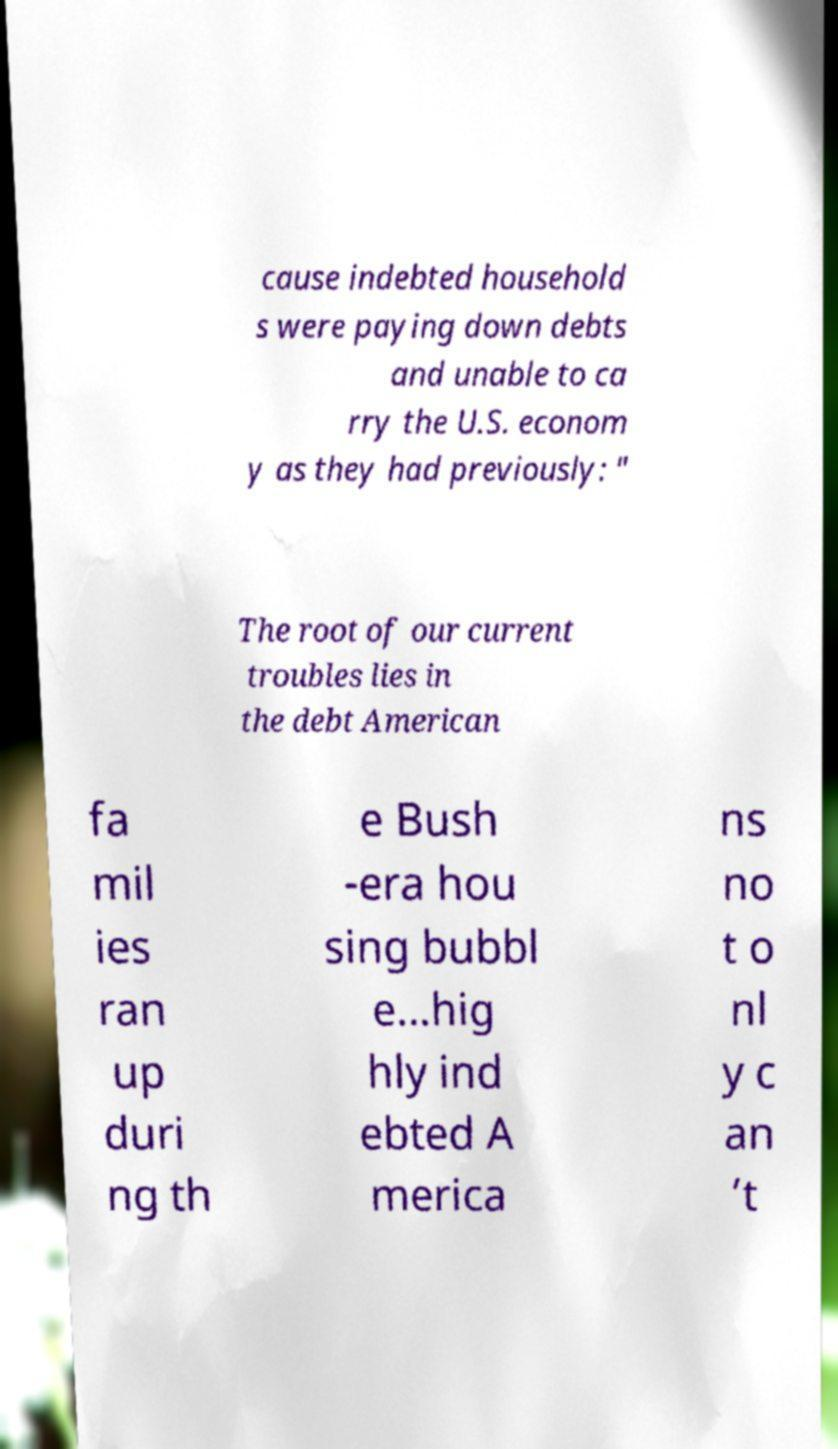For documentation purposes, I need the text within this image transcribed. Could you provide that? cause indebted household s were paying down debts and unable to ca rry the U.S. econom y as they had previously: " The root of our current troubles lies in the debt American fa mil ies ran up duri ng th e Bush -era hou sing bubbl e...hig hly ind ebted A merica ns no t o nl y c an ’t 